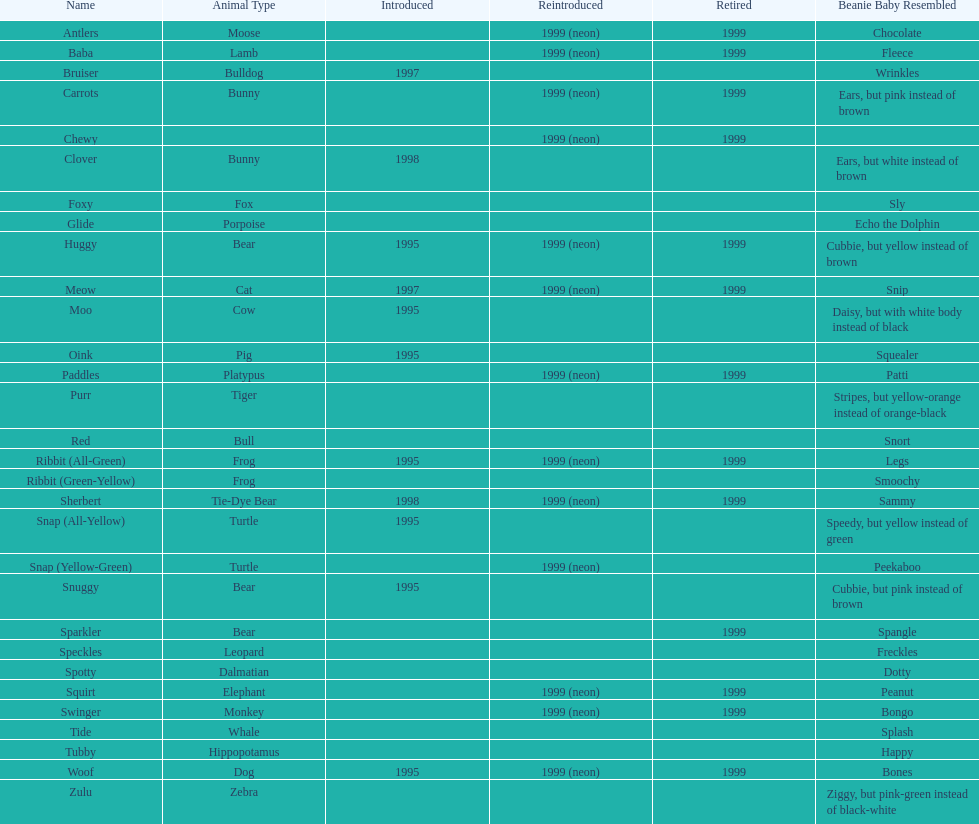What is the name of the final pillow pal listed on this chart? Zulu. 